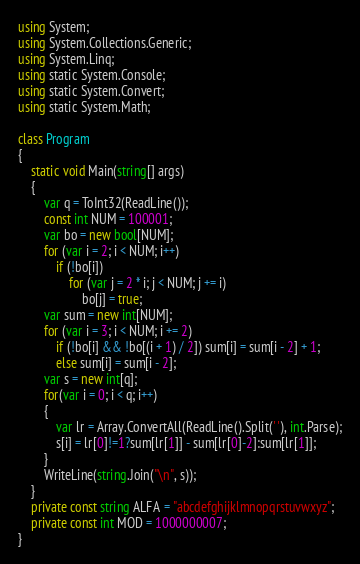<code> <loc_0><loc_0><loc_500><loc_500><_C#_>using System;
using System.Collections.Generic;
using System.Linq;
using static System.Console;
using static System.Convert;
using static System.Math;

class Program
{
    static void Main(string[] args)
    {
        var q = ToInt32(ReadLine());
        const int NUM = 100001;
        var bo = new bool[NUM];
        for (var i = 2; i < NUM; i++)
            if (!bo[i])
                for (var j = 2 * i; j < NUM; j += i)
                    bo[j] = true;
        var sum = new int[NUM];
        for (var i = 3; i < NUM; i += 2)
            if (!bo[i] && !bo[(i + 1) / 2]) sum[i] = sum[i - 2] + 1;
            else sum[i] = sum[i - 2];
        var s = new int[q];
        for(var i = 0; i < q; i++)
        {
            var lr = Array.ConvertAll(ReadLine().Split(' '), int.Parse);
            s[i] = lr[0]!=1?sum[lr[1]] - sum[lr[0]-2]:sum[lr[1]];
        }
        WriteLine(string.Join("\n", s));
    }
    private const string ALFA = "abcdefghijklmnopqrstuvwxyz";
    private const int MOD = 1000000007;
}
</code> 